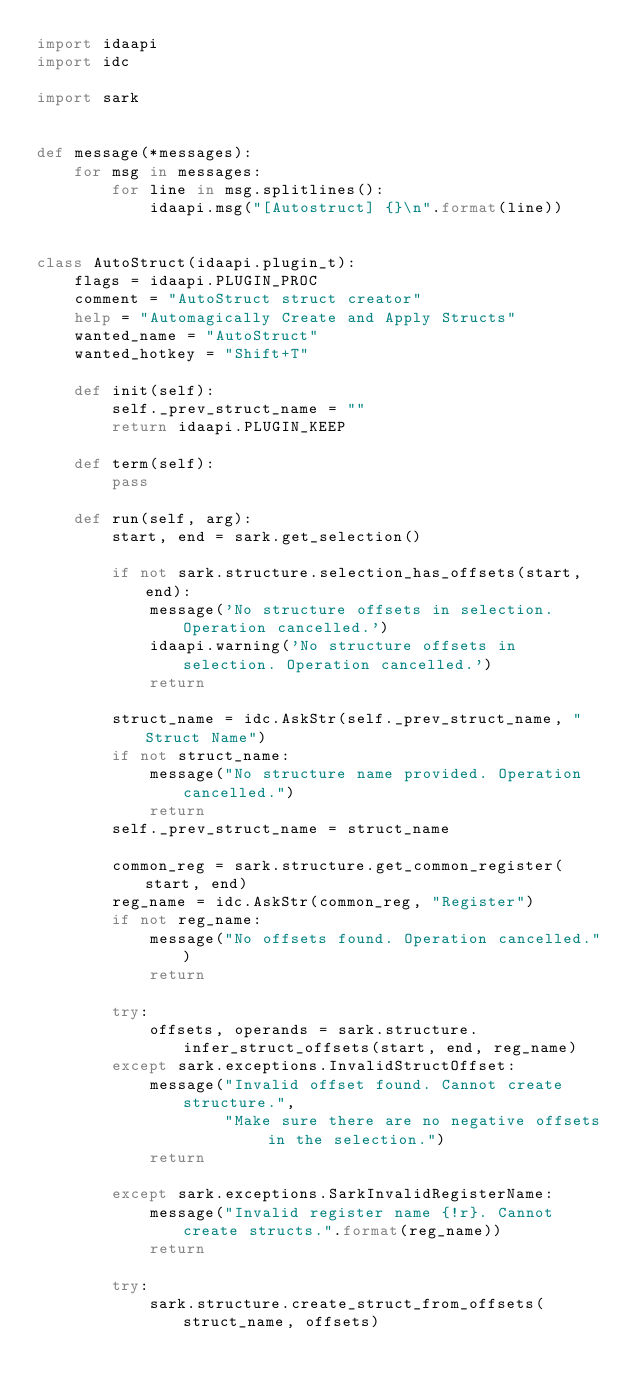<code> <loc_0><loc_0><loc_500><loc_500><_Python_>import idaapi
import idc

import sark


def message(*messages):
    for msg in messages:
        for line in msg.splitlines():
            idaapi.msg("[Autostruct] {}\n".format(line))


class AutoStruct(idaapi.plugin_t):
    flags = idaapi.PLUGIN_PROC
    comment = "AutoStruct struct creator"
    help = "Automagically Create and Apply Structs"
    wanted_name = "AutoStruct"
    wanted_hotkey = "Shift+T"

    def init(self):
        self._prev_struct_name = ""
        return idaapi.PLUGIN_KEEP

    def term(self):
        pass

    def run(self, arg):
        start, end = sark.get_selection()

        if not sark.structure.selection_has_offsets(start, end):
            message('No structure offsets in selection. Operation cancelled.')
            idaapi.warning('No structure offsets in selection. Operation cancelled.')
            return

        struct_name = idc.AskStr(self._prev_struct_name, "Struct Name")
        if not struct_name:
            message("No structure name provided. Operation cancelled.")
            return
        self._prev_struct_name = struct_name

        common_reg = sark.structure.get_common_register(start, end)
        reg_name = idc.AskStr(common_reg, "Register")
        if not reg_name:
            message("No offsets found. Operation cancelled.")
            return

        try:
            offsets, operands = sark.structure.infer_struct_offsets(start, end, reg_name)
        except sark.exceptions.InvalidStructOffset:
            message("Invalid offset found. Cannot create structure.",
                    "Make sure there are no negative offsets in the selection.")
            return

        except sark.exceptions.SarkInvalidRegisterName:
            message("Invalid register name {!r}. Cannot create structs.".format(reg_name))
            return

        try:
            sark.structure.create_struct_from_offsets(struct_name, offsets)</code> 